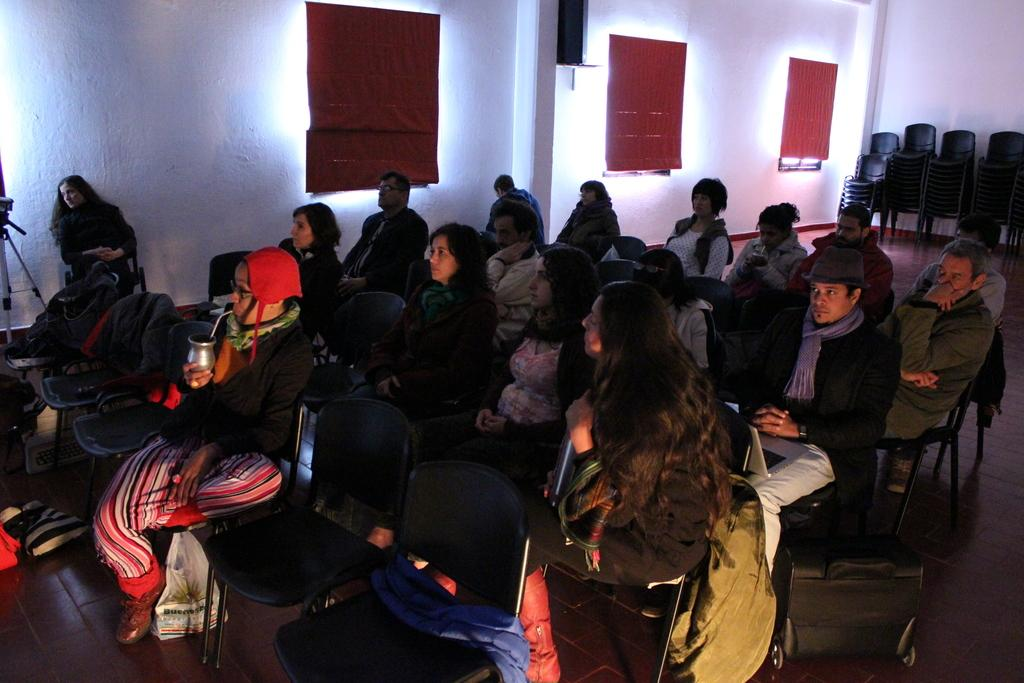What are the people in the image doing? The people in the image are sitting in chairs. Can you describe the gender be determined for the people in the image? Yes, there are men and women in the image. What can be seen in the background of the image? There are red color curtains and a wall in the background of the image. What type of salt is being used to season the food in the image? There is no food or salt present in the image; it features people sitting in chairs with a background of red color curtains and a wall. How is the glue being applied to the surface in the image? There is no glue or surface present in the image; it features people sitting in chairs with a background of red color curtains and a wall. 